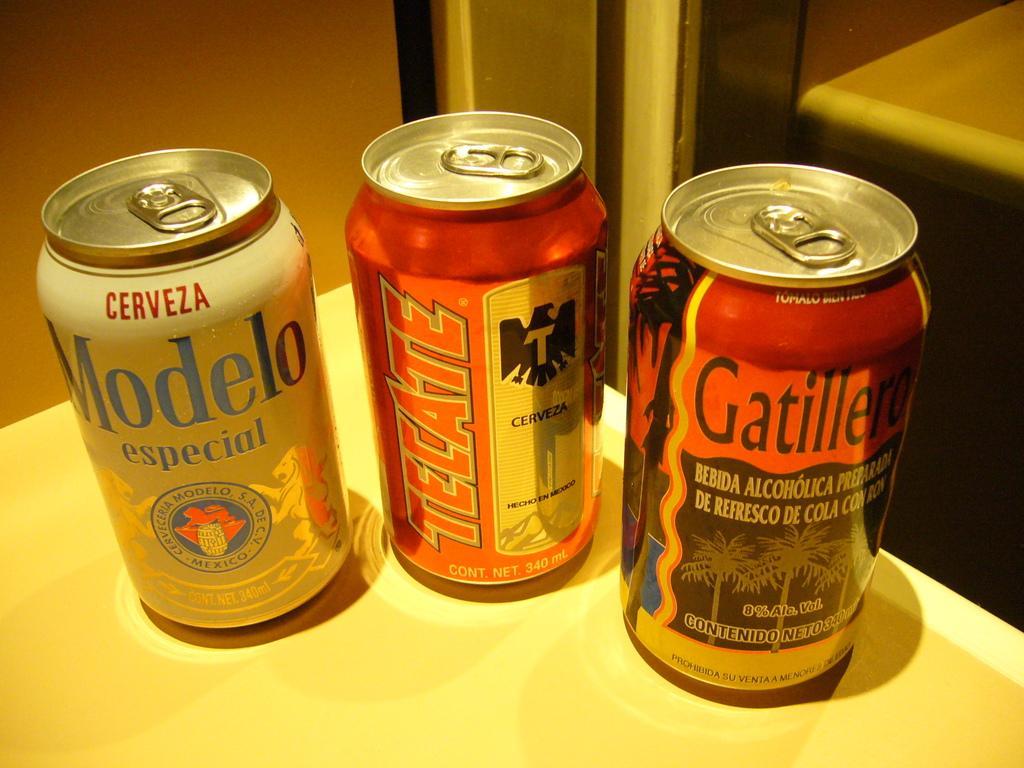Please provide a concise description of this image. This image consists of three coke bottles. Two are in red color, one is in white color. They are placed on a table, which is in white color. 